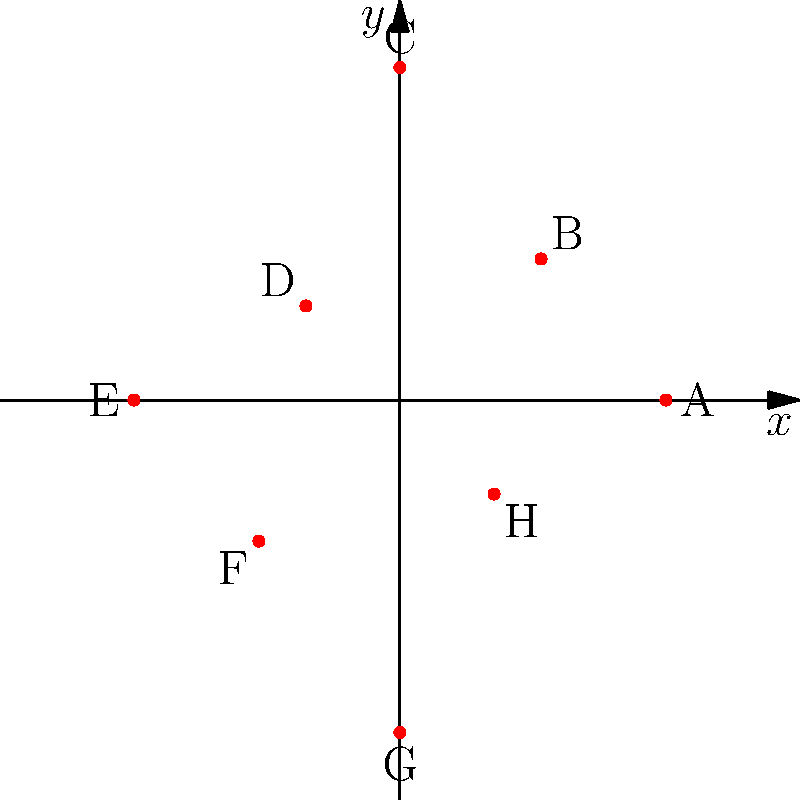In the polar coordinate system shown above, community service locations are mapped for a diversion program. If the angle $\theta$ is measured counterclockwise from the positive x-axis and $r$ represents the distance from the origin in miles, which location is furthest from the city center (origin) and what is its distance? To determine which location is furthest from the city center and its distance, we need to compare the $r$ values for each point, as $r$ represents the distance from the origin in polar coordinates.

Let's list out the $r$ values for each point:

A: $r = 4$
B: $r = 3$
C: $r = 5$
D: $r = 2$
E: $r = 4$
F: $r = 3$
G: $r = 5$
H: $r = 2$

The largest $r$ value is 5, which occurs at two points: C and G.

Both points C and G are 5 miles away from the city center. We can choose either one as our answer, but for consistency, let's choose the one that appears first when moving counterclockwise from the positive x-axis.

Point C is located at $\theta = \frac{\pi}{2}$ (90°), while point G is at $\theta = \frac{3\pi}{2}$ (270°).

Therefore, point C is the first to appear counterclockwise and is our answer.
Answer: C, 5 miles 